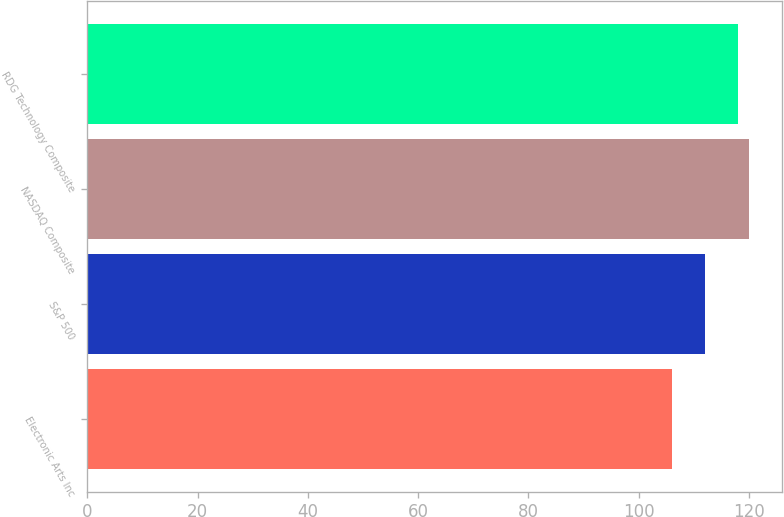Convert chart. <chart><loc_0><loc_0><loc_500><loc_500><bar_chart><fcel>Electronic Arts Inc<fcel>S&P 500<fcel>NASDAQ Composite<fcel>RDG Technology Composite<nl><fcel>106<fcel>112<fcel>120<fcel>118<nl></chart> 